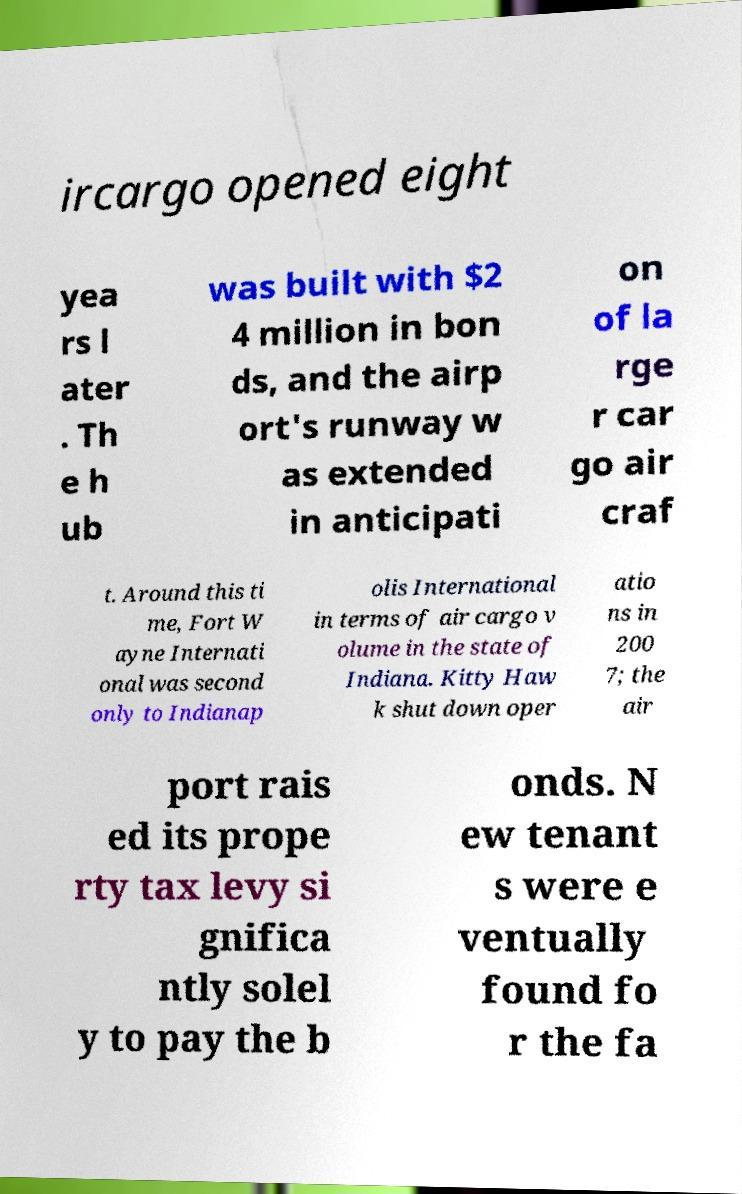Could you extract and type out the text from this image? ircargo opened eight yea rs l ater . Th e h ub was built with $2 4 million in bon ds, and the airp ort's runway w as extended in anticipati on of la rge r car go air craf t. Around this ti me, Fort W ayne Internati onal was second only to Indianap olis International in terms of air cargo v olume in the state of Indiana. Kitty Haw k shut down oper atio ns in 200 7; the air port rais ed its prope rty tax levy si gnifica ntly solel y to pay the b onds. N ew tenant s were e ventually found fo r the fa 